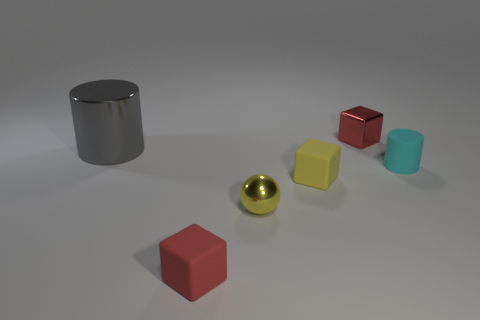Can you describe the lighting in the scene? The scene is lit with what appears to be a soft, diffuse overhead light source, casting gentle shadows directly beneath the objects, indicating the light source is located above the scene. 